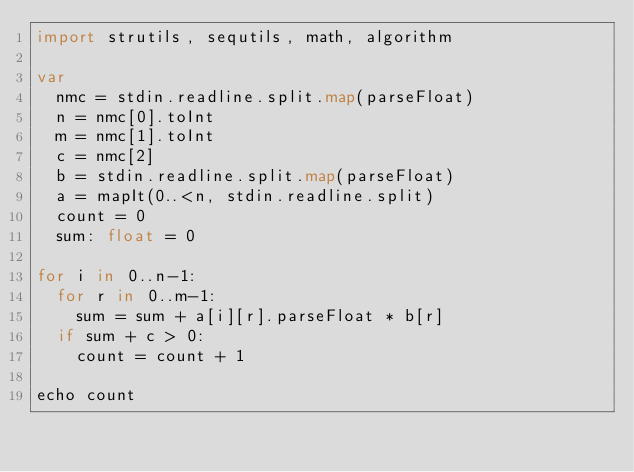Convert code to text. <code><loc_0><loc_0><loc_500><loc_500><_Nim_>import strutils, sequtils, math, algorithm

var
  nmc = stdin.readline.split.map(parseFloat)
  n = nmc[0].toInt
  m = nmc[1].toInt
  c = nmc[2]
  b = stdin.readline.split.map(parseFloat)
  a = mapIt(0..<n, stdin.readline.split)
  count = 0
  sum: float = 0

for i in 0..n-1:
  for r in 0..m-1:
    sum = sum + a[i][r].parseFloat * b[r]
  if sum + c > 0:
    count = count + 1

echo count</code> 